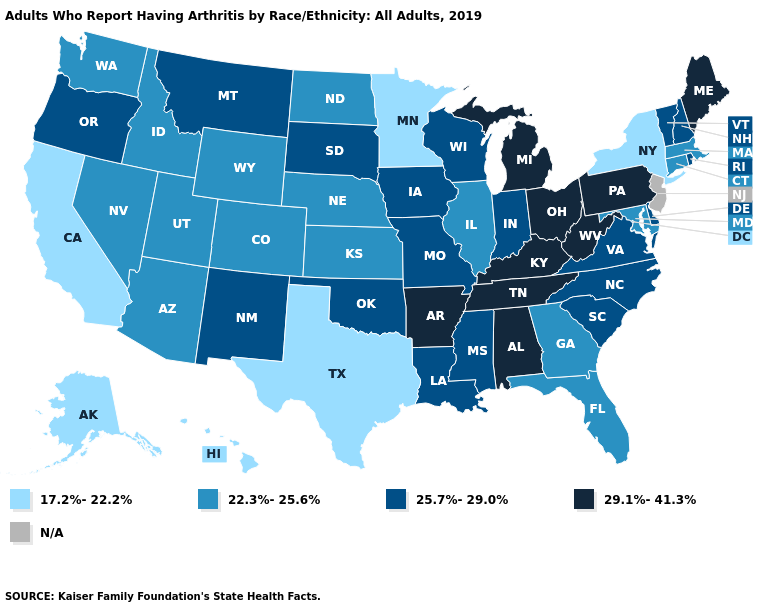Among the states that border Vermont , which have the lowest value?
Give a very brief answer. New York. Which states hav the highest value in the MidWest?
Keep it brief. Michigan, Ohio. Which states hav the highest value in the South?
Give a very brief answer. Alabama, Arkansas, Kentucky, Tennessee, West Virginia. What is the highest value in the USA?
Keep it brief. 29.1%-41.3%. Is the legend a continuous bar?
Answer briefly. No. Name the states that have a value in the range 29.1%-41.3%?
Give a very brief answer. Alabama, Arkansas, Kentucky, Maine, Michigan, Ohio, Pennsylvania, Tennessee, West Virginia. What is the lowest value in the South?
Answer briefly. 17.2%-22.2%. Name the states that have a value in the range N/A?
Be succinct. New Jersey. Name the states that have a value in the range 25.7%-29.0%?
Answer briefly. Delaware, Indiana, Iowa, Louisiana, Mississippi, Missouri, Montana, New Hampshire, New Mexico, North Carolina, Oklahoma, Oregon, Rhode Island, South Carolina, South Dakota, Vermont, Virginia, Wisconsin. What is the value of North Carolina?
Give a very brief answer. 25.7%-29.0%. Is the legend a continuous bar?
Give a very brief answer. No. What is the value of Oregon?
Give a very brief answer. 25.7%-29.0%. Does Oregon have the highest value in the USA?
Answer briefly. No. Name the states that have a value in the range 25.7%-29.0%?
Short answer required. Delaware, Indiana, Iowa, Louisiana, Mississippi, Missouri, Montana, New Hampshire, New Mexico, North Carolina, Oklahoma, Oregon, Rhode Island, South Carolina, South Dakota, Vermont, Virginia, Wisconsin. What is the highest value in the MidWest ?
Give a very brief answer. 29.1%-41.3%. 